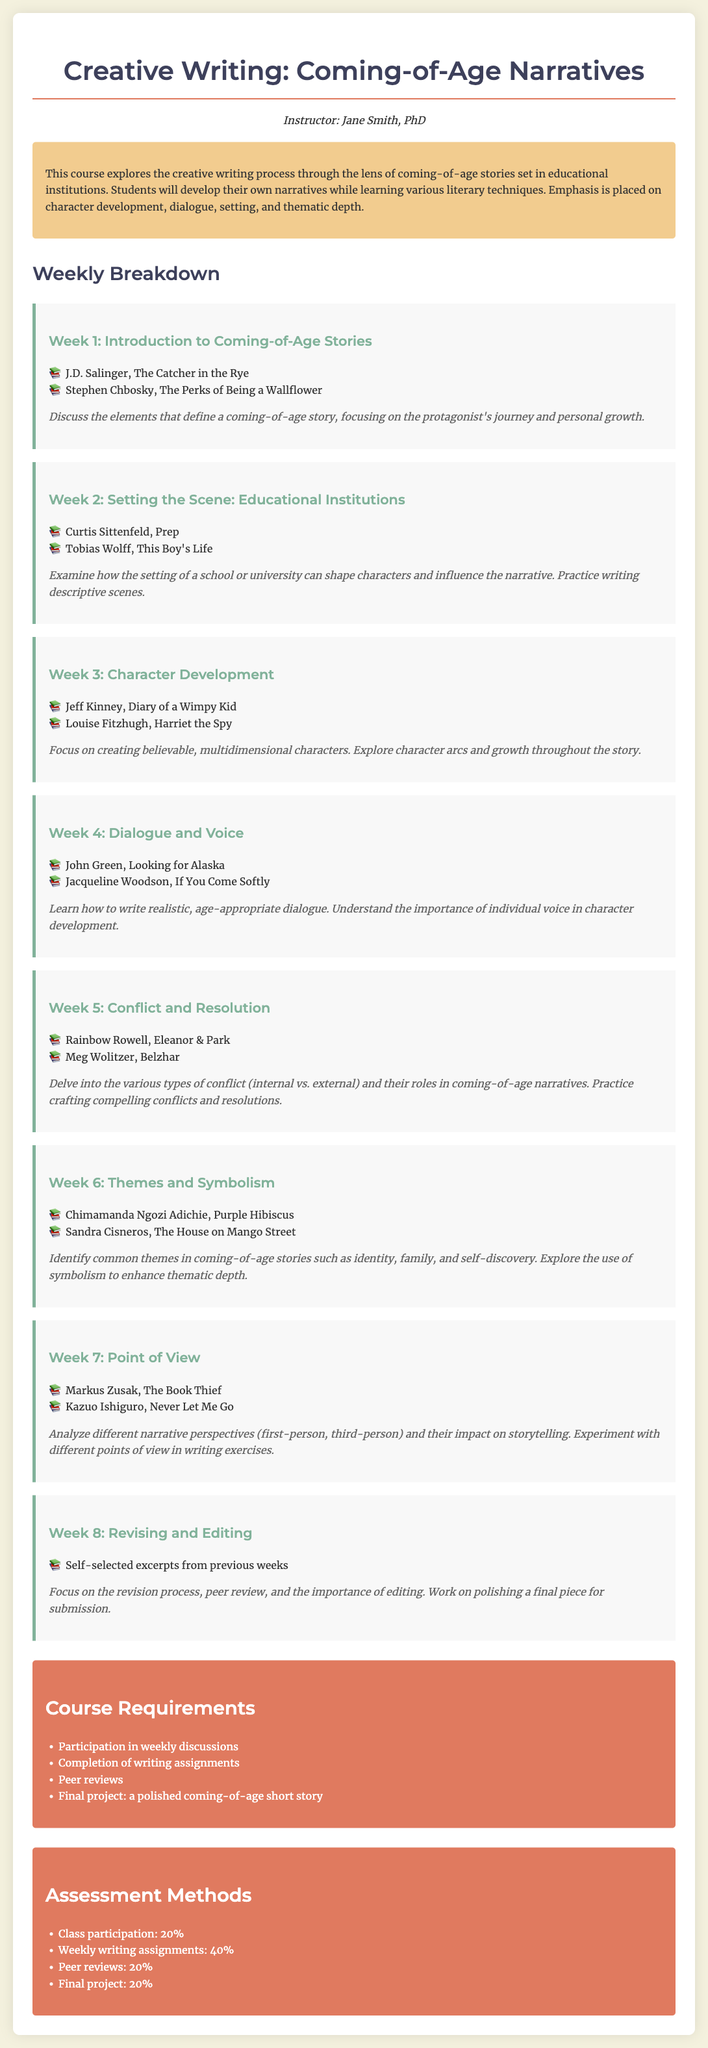What is the course title? The course title is stated at the top of the syllabus.
Answer: Creative Writing: Coming-of-Age Narratives Who is the instructor for the course? The instructor's name is provided under the course title.
Answer: Jane Smith, PhD What is the focus of the course? The focus of the course is mentioned in the course description section.
Answer: Coming-of-age stories set in educational institutions How many weeks is the course structured? The weekly breakdown section implies the length of the course through a series of weekly topics.
Answer: 8 weeks What percentage of the assessment is based on class participation? The assessment methods section lists the percentage allocated for class participation.
Answer: 20% Which reading is assigned for Week 3? The readings list an author and title for each week, focusing on Week 3 here.
Answer: Jeff Kinney, Diary of a Wimpy Kid What literary technique is highlighted in Week 4? The annotations for Week 4 specify the technique being taught.
Answer: Dialogue and Voice What type of project is required for the final submission? The course requirements detail what the final project entails.
Answer: A polished coming-of-age short story 